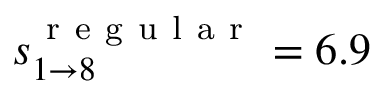<formula> <loc_0><loc_0><loc_500><loc_500>s _ { 1 \rightarrow 8 } ^ { r e g u l a r } = 6 . 9</formula> 